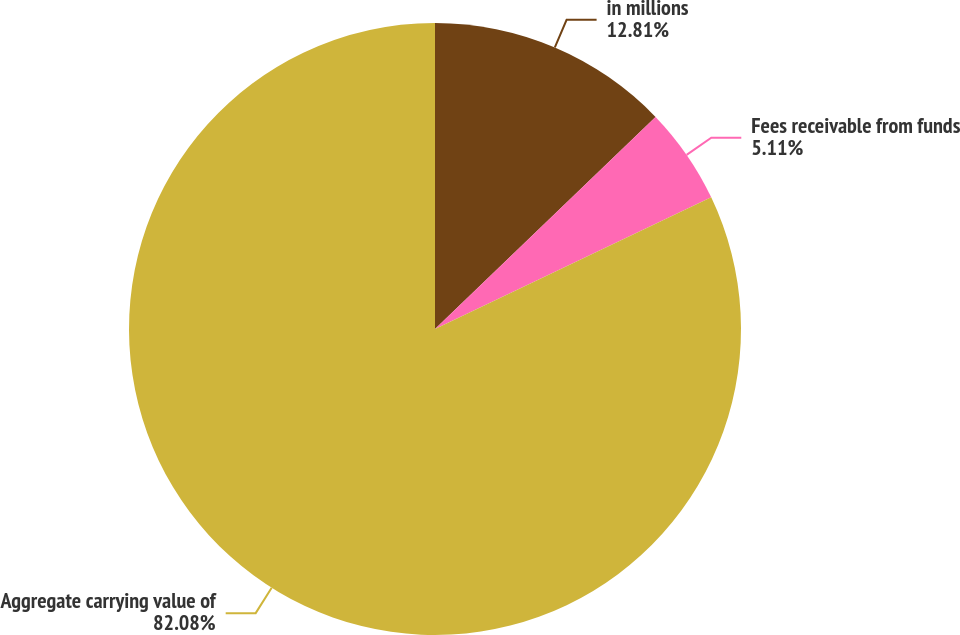Convert chart to OTSL. <chart><loc_0><loc_0><loc_500><loc_500><pie_chart><fcel>in millions<fcel>Fees receivable from funds<fcel>Aggregate carrying value of<nl><fcel>12.81%<fcel>5.11%<fcel>82.08%<nl></chart> 